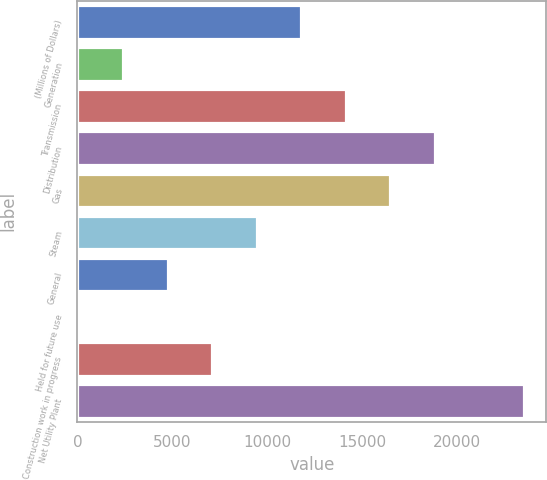Convert chart to OTSL. <chart><loc_0><loc_0><loc_500><loc_500><bar_chart><fcel>(Millions of Dollars)<fcel>Generation<fcel>Transmission<fcel>Distribution<fcel>Gas<fcel>Steam<fcel>General<fcel>Held for future use<fcel>Construction work in progress<fcel>Net Utility Plant<nl><fcel>11779<fcel>2405.4<fcel>14122.4<fcel>18809.2<fcel>16465.8<fcel>9435.6<fcel>4748.8<fcel>62<fcel>7092.2<fcel>23496<nl></chart> 